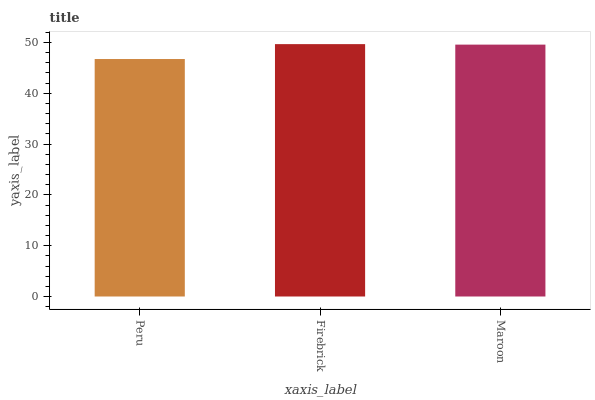Is Maroon the minimum?
Answer yes or no. No. Is Maroon the maximum?
Answer yes or no. No. Is Firebrick greater than Maroon?
Answer yes or no. Yes. Is Maroon less than Firebrick?
Answer yes or no. Yes. Is Maroon greater than Firebrick?
Answer yes or no. No. Is Firebrick less than Maroon?
Answer yes or no. No. Is Maroon the high median?
Answer yes or no. Yes. Is Maroon the low median?
Answer yes or no. Yes. Is Firebrick the high median?
Answer yes or no. No. Is Firebrick the low median?
Answer yes or no. No. 